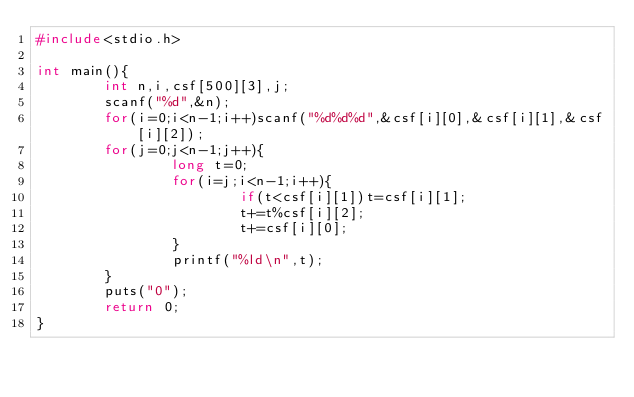<code> <loc_0><loc_0><loc_500><loc_500><_C_>#include<stdio.h>

int main(){
		int n,i,csf[500][3],j;
		scanf("%d",&n);
		for(i=0;i<n-1;i++)scanf("%d%d%d",&csf[i][0],&csf[i][1],&csf[i][2]); 
		for(j=0;j<n-1;j++){
				long t=0;
				for(i=j;i<n-1;i++){
						if(t<csf[i][1])t=csf[i][1];
						t+=t%csf[i][2];
						t+=csf[i][0];
				}
				printf("%ld\n",t);
		}
		puts("0");
		return 0;
}
</code> 